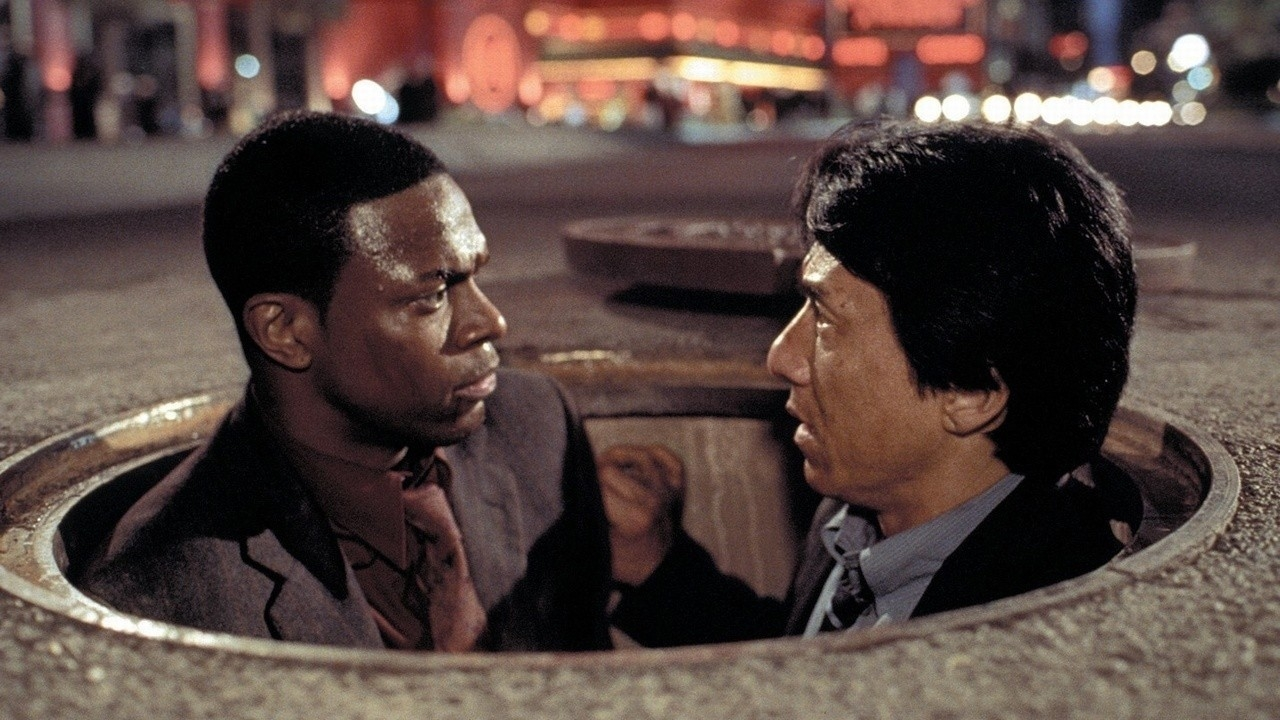Can you describe the mood and atmosphere in more detail? The mood in this image is one of high tension and seriousness. Both characters exhibit intense, focused expressions as they converse, hinting at the gravity of their situation. The atmosphere is enhanced by the nocturnal city setting, where the ambient lights blur into glowing orbs, creating a sense of urgency and encapsulating the fast-paced, perilous scenario they are in. The red-lit fountain in the background adds a dramatic flair to the scene, suggesting an environment fraught with danger and unexpected twists. 